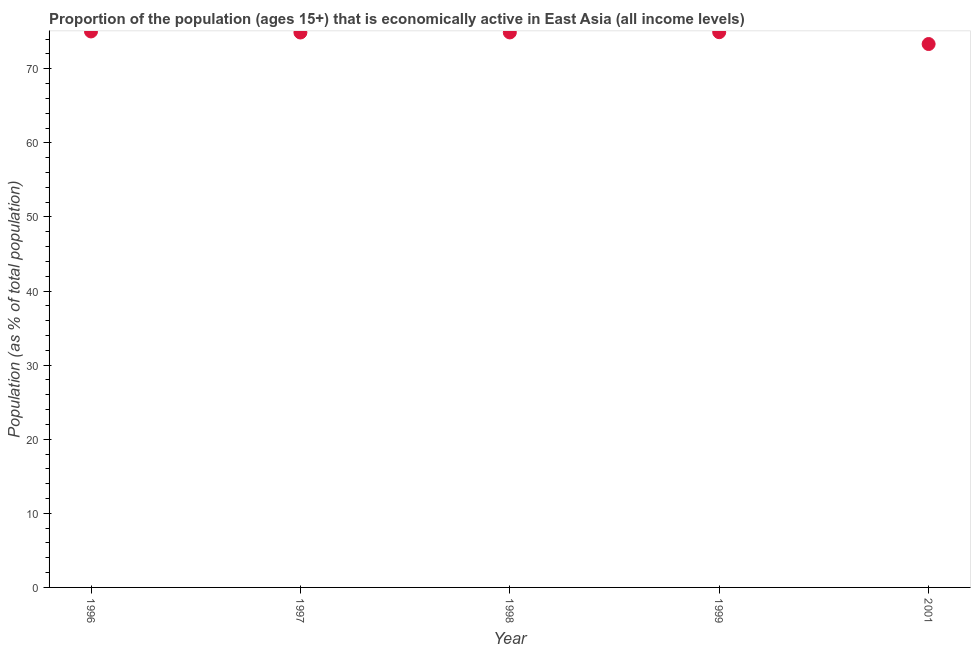What is the percentage of economically active population in 1996?
Make the answer very short. 75.04. Across all years, what is the maximum percentage of economically active population?
Your response must be concise. 75.04. Across all years, what is the minimum percentage of economically active population?
Your answer should be very brief. 73.34. In which year was the percentage of economically active population maximum?
Keep it short and to the point. 1996. What is the sum of the percentage of economically active population?
Keep it short and to the point. 373.1. What is the difference between the percentage of economically active population in 1998 and 1999?
Provide a succinct answer. -0.03. What is the average percentage of economically active population per year?
Your answer should be compact. 74.62. What is the median percentage of economically active population?
Your response must be concise. 74.9. In how many years, is the percentage of economically active population greater than 70 %?
Provide a short and direct response. 5. Do a majority of the years between 1999 and 2001 (inclusive) have percentage of economically active population greater than 62 %?
Ensure brevity in your answer.  Yes. What is the ratio of the percentage of economically active population in 1996 to that in 1998?
Offer a terse response. 1. Is the percentage of economically active population in 1996 less than that in 1997?
Provide a short and direct response. No. Is the difference between the percentage of economically active population in 1997 and 1999 greater than the difference between any two years?
Offer a terse response. No. What is the difference between the highest and the second highest percentage of economically active population?
Ensure brevity in your answer.  0.1. Is the sum of the percentage of economically active population in 1998 and 2001 greater than the maximum percentage of economically active population across all years?
Your response must be concise. Yes. What is the difference between the highest and the lowest percentage of economically active population?
Your answer should be very brief. 1.7. In how many years, is the percentage of economically active population greater than the average percentage of economically active population taken over all years?
Give a very brief answer. 4. What is the difference between two consecutive major ticks on the Y-axis?
Provide a short and direct response. 10. Does the graph contain grids?
Provide a short and direct response. No. What is the title of the graph?
Keep it short and to the point. Proportion of the population (ages 15+) that is economically active in East Asia (all income levels). What is the label or title of the X-axis?
Give a very brief answer. Year. What is the label or title of the Y-axis?
Your answer should be very brief. Population (as % of total population). What is the Population (as % of total population) in 1996?
Provide a succinct answer. 75.04. What is the Population (as % of total population) in 1997?
Keep it short and to the point. 74.89. What is the Population (as % of total population) in 1998?
Your answer should be very brief. 74.9. What is the Population (as % of total population) in 1999?
Provide a short and direct response. 74.94. What is the Population (as % of total population) in 2001?
Provide a succinct answer. 73.34. What is the difference between the Population (as % of total population) in 1996 and 1997?
Give a very brief answer. 0.14. What is the difference between the Population (as % of total population) in 1996 and 1998?
Ensure brevity in your answer.  0.13. What is the difference between the Population (as % of total population) in 1996 and 1999?
Provide a short and direct response. 0.1. What is the difference between the Population (as % of total population) in 1996 and 2001?
Ensure brevity in your answer.  1.7. What is the difference between the Population (as % of total population) in 1997 and 1998?
Ensure brevity in your answer.  -0.01. What is the difference between the Population (as % of total population) in 1997 and 1999?
Provide a succinct answer. -0.04. What is the difference between the Population (as % of total population) in 1997 and 2001?
Give a very brief answer. 1.56. What is the difference between the Population (as % of total population) in 1998 and 1999?
Provide a short and direct response. -0.03. What is the difference between the Population (as % of total population) in 1998 and 2001?
Provide a short and direct response. 1.56. What is the difference between the Population (as % of total population) in 1999 and 2001?
Your response must be concise. 1.6. What is the ratio of the Population (as % of total population) in 1996 to that in 1998?
Offer a terse response. 1. What is the ratio of the Population (as % of total population) in 1996 to that in 1999?
Your answer should be very brief. 1. What is the ratio of the Population (as % of total population) in 1996 to that in 2001?
Offer a very short reply. 1.02. What is the ratio of the Population (as % of total population) in 1997 to that in 1999?
Offer a very short reply. 1. What is the ratio of the Population (as % of total population) in 1998 to that in 1999?
Your answer should be compact. 1. What is the ratio of the Population (as % of total population) in 1998 to that in 2001?
Your answer should be very brief. 1.02. 